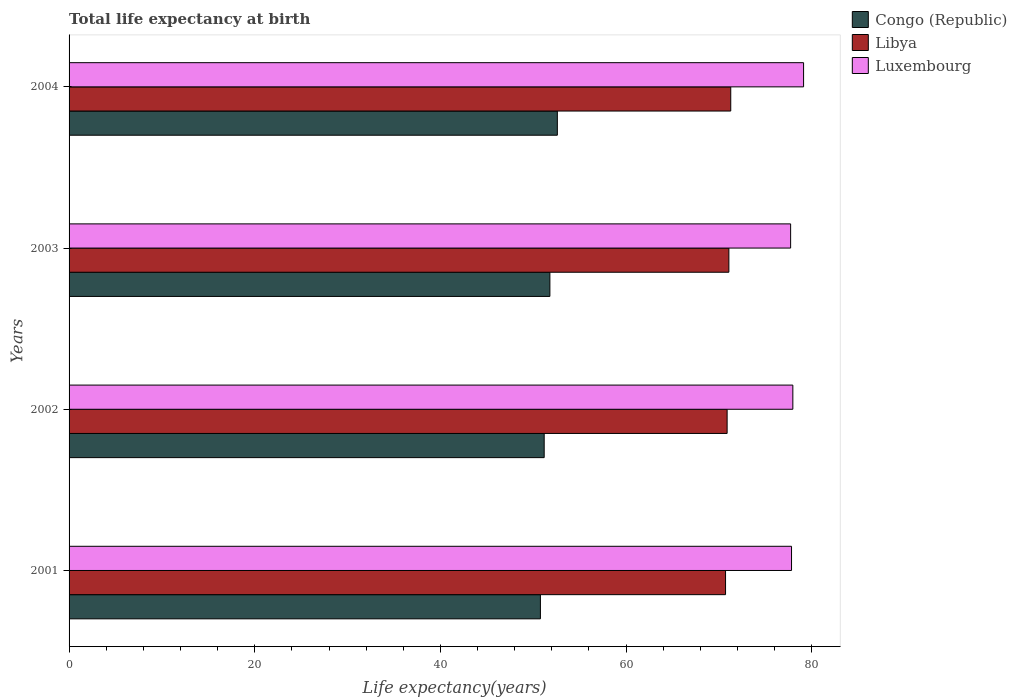How many different coloured bars are there?
Your answer should be very brief. 3. Are the number of bars per tick equal to the number of legend labels?
Your answer should be very brief. Yes. Are the number of bars on each tick of the Y-axis equal?
Provide a short and direct response. Yes. How many bars are there on the 1st tick from the top?
Keep it short and to the point. 3. How many bars are there on the 2nd tick from the bottom?
Your response must be concise. 3. What is the label of the 1st group of bars from the top?
Offer a very short reply. 2004. What is the life expectancy at birth in in Libya in 2002?
Your response must be concise. 70.89. Across all years, what is the maximum life expectancy at birth in in Luxembourg?
Offer a terse response. 79.12. Across all years, what is the minimum life expectancy at birth in in Congo (Republic)?
Ensure brevity in your answer.  50.77. In which year was the life expectancy at birth in in Congo (Republic) maximum?
Make the answer very short. 2004. In which year was the life expectancy at birth in in Luxembourg minimum?
Ensure brevity in your answer.  2003. What is the total life expectancy at birth in in Libya in the graph?
Provide a succinct answer. 283.95. What is the difference between the life expectancy at birth in in Congo (Republic) in 2002 and that in 2004?
Keep it short and to the point. -1.42. What is the difference between the life expectancy at birth in in Congo (Republic) in 2003 and the life expectancy at birth in in Luxembourg in 2002?
Keep it short and to the point. -26.17. What is the average life expectancy at birth in in Congo (Republic) per year?
Provide a short and direct response. 51.59. In the year 2004, what is the difference between the life expectancy at birth in in Libya and life expectancy at birth in in Congo (Republic)?
Offer a very short reply. 18.68. What is the ratio of the life expectancy at birth in in Luxembourg in 2003 to that in 2004?
Ensure brevity in your answer.  0.98. Is the life expectancy at birth in in Libya in 2002 less than that in 2003?
Offer a terse response. Yes. Is the difference between the life expectancy at birth in in Libya in 2001 and 2002 greater than the difference between the life expectancy at birth in in Congo (Republic) in 2001 and 2002?
Your answer should be very brief. Yes. What is the difference between the highest and the second highest life expectancy at birth in in Libya?
Make the answer very short. 0.2. What is the difference between the highest and the lowest life expectancy at birth in in Libya?
Offer a very short reply. 0.56. Is the sum of the life expectancy at birth in in Luxembourg in 2003 and 2004 greater than the maximum life expectancy at birth in in Congo (Republic) across all years?
Ensure brevity in your answer.  Yes. What does the 2nd bar from the top in 2002 represents?
Your answer should be very brief. Libya. What does the 1st bar from the bottom in 2002 represents?
Make the answer very short. Congo (Republic). How many bars are there?
Keep it short and to the point. 12. Are the values on the major ticks of X-axis written in scientific E-notation?
Your response must be concise. No. How many legend labels are there?
Offer a very short reply. 3. What is the title of the graph?
Ensure brevity in your answer.  Total life expectancy at birth. Does "Liberia" appear as one of the legend labels in the graph?
Ensure brevity in your answer.  No. What is the label or title of the X-axis?
Provide a succinct answer. Life expectancy(years). What is the label or title of the Y-axis?
Keep it short and to the point. Years. What is the Life expectancy(years) of Congo (Republic) in 2001?
Offer a terse response. 50.77. What is the Life expectancy(years) in Libya in 2001?
Make the answer very short. 70.72. What is the Life expectancy(years) of Luxembourg in 2001?
Ensure brevity in your answer.  77.82. What is the Life expectancy(years) of Congo (Republic) in 2002?
Your response must be concise. 51.18. What is the Life expectancy(years) of Libya in 2002?
Offer a very short reply. 70.89. What is the Life expectancy(years) of Luxembourg in 2002?
Keep it short and to the point. 77.97. What is the Life expectancy(years) in Congo (Republic) in 2003?
Your response must be concise. 51.79. What is the Life expectancy(years) in Libya in 2003?
Provide a short and direct response. 71.07. What is the Life expectancy(years) in Luxembourg in 2003?
Your response must be concise. 77.73. What is the Life expectancy(years) of Congo (Republic) in 2004?
Your answer should be very brief. 52.6. What is the Life expectancy(years) of Libya in 2004?
Provide a short and direct response. 71.28. What is the Life expectancy(years) of Luxembourg in 2004?
Keep it short and to the point. 79.12. Across all years, what is the maximum Life expectancy(years) in Congo (Republic)?
Give a very brief answer. 52.6. Across all years, what is the maximum Life expectancy(years) of Libya?
Your answer should be very brief. 71.28. Across all years, what is the maximum Life expectancy(years) of Luxembourg?
Make the answer very short. 79.12. Across all years, what is the minimum Life expectancy(years) of Congo (Republic)?
Keep it short and to the point. 50.77. Across all years, what is the minimum Life expectancy(years) in Libya?
Keep it short and to the point. 70.72. Across all years, what is the minimum Life expectancy(years) in Luxembourg?
Your answer should be very brief. 77.73. What is the total Life expectancy(years) in Congo (Republic) in the graph?
Make the answer very short. 206.34. What is the total Life expectancy(years) of Libya in the graph?
Offer a very short reply. 283.95. What is the total Life expectancy(years) in Luxembourg in the graph?
Offer a terse response. 312.64. What is the difference between the Life expectancy(years) of Congo (Republic) in 2001 and that in 2002?
Your response must be concise. -0.41. What is the difference between the Life expectancy(years) of Libya in 2001 and that in 2002?
Offer a terse response. -0.17. What is the difference between the Life expectancy(years) in Luxembourg in 2001 and that in 2002?
Make the answer very short. -0.14. What is the difference between the Life expectancy(years) of Congo (Republic) in 2001 and that in 2003?
Offer a very short reply. -1.02. What is the difference between the Life expectancy(years) of Libya in 2001 and that in 2003?
Your answer should be very brief. -0.36. What is the difference between the Life expectancy(years) in Luxembourg in 2001 and that in 2003?
Make the answer very short. 0.1. What is the difference between the Life expectancy(years) of Congo (Republic) in 2001 and that in 2004?
Ensure brevity in your answer.  -1.82. What is the difference between the Life expectancy(years) of Libya in 2001 and that in 2004?
Keep it short and to the point. -0.56. What is the difference between the Life expectancy(years) of Luxembourg in 2001 and that in 2004?
Make the answer very short. -1.3. What is the difference between the Life expectancy(years) in Congo (Republic) in 2002 and that in 2003?
Provide a short and direct response. -0.61. What is the difference between the Life expectancy(years) in Libya in 2002 and that in 2003?
Offer a terse response. -0.19. What is the difference between the Life expectancy(years) of Luxembourg in 2002 and that in 2003?
Offer a very short reply. 0.24. What is the difference between the Life expectancy(years) of Congo (Republic) in 2002 and that in 2004?
Provide a succinct answer. -1.42. What is the difference between the Life expectancy(years) in Libya in 2002 and that in 2004?
Your answer should be compact. -0.39. What is the difference between the Life expectancy(years) of Luxembourg in 2002 and that in 2004?
Give a very brief answer. -1.16. What is the difference between the Life expectancy(years) in Congo (Republic) in 2003 and that in 2004?
Ensure brevity in your answer.  -0.8. What is the difference between the Life expectancy(years) of Libya in 2003 and that in 2004?
Give a very brief answer. -0.2. What is the difference between the Life expectancy(years) in Luxembourg in 2003 and that in 2004?
Your answer should be very brief. -1.4. What is the difference between the Life expectancy(years) in Congo (Republic) in 2001 and the Life expectancy(years) in Libya in 2002?
Your response must be concise. -20.11. What is the difference between the Life expectancy(years) of Congo (Republic) in 2001 and the Life expectancy(years) of Luxembourg in 2002?
Make the answer very short. -27.19. What is the difference between the Life expectancy(years) in Libya in 2001 and the Life expectancy(years) in Luxembourg in 2002?
Offer a terse response. -7.25. What is the difference between the Life expectancy(years) of Congo (Republic) in 2001 and the Life expectancy(years) of Libya in 2003?
Provide a short and direct response. -20.3. What is the difference between the Life expectancy(years) in Congo (Republic) in 2001 and the Life expectancy(years) in Luxembourg in 2003?
Keep it short and to the point. -26.95. What is the difference between the Life expectancy(years) of Libya in 2001 and the Life expectancy(years) of Luxembourg in 2003?
Provide a succinct answer. -7.01. What is the difference between the Life expectancy(years) in Congo (Republic) in 2001 and the Life expectancy(years) in Libya in 2004?
Provide a succinct answer. -20.5. What is the difference between the Life expectancy(years) of Congo (Republic) in 2001 and the Life expectancy(years) of Luxembourg in 2004?
Your response must be concise. -28.35. What is the difference between the Life expectancy(years) in Libya in 2001 and the Life expectancy(years) in Luxembourg in 2004?
Your answer should be very brief. -8.41. What is the difference between the Life expectancy(years) of Congo (Republic) in 2002 and the Life expectancy(years) of Libya in 2003?
Give a very brief answer. -19.89. What is the difference between the Life expectancy(years) in Congo (Republic) in 2002 and the Life expectancy(years) in Luxembourg in 2003?
Your answer should be compact. -26.55. What is the difference between the Life expectancy(years) of Libya in 2002 and the Life expectancy(years) of Luxembourg in 2003?
Keep it short and to the point. -6.84. What is the difference between the Life expectancy(years) in Congo (Republic) in 2002 and the Life expectancy(years) in Libya in 2004?
Offer a terse response. -20.1. What is the difference between the Life expectancy(years) in Congo (Republic) in 2002 and the Life expectancy(years) in Luxembourg in 2004?
Your response must be concise. -27.94. What is the difference between the Life expectancy(years) of Libya in 2002 and the Life expectancy(years) of Luxembourg in 2004?
Provide a succinct answer. -8.24. What is the difference between the Life expectancy(years) of Congo (Republic) in 2003 and the Life expectancy(years) of Libya in 2004?
Give a very brief answer. -19.48. What is the difference between the Life expectancy(years) in Congo (Republic) in 2003 and the Life expectancy(years) in Luxembourg in 2004?
Your answer should be very brief. -27.33. What is the difference between the Life expectancy(years) of Libya in 2003 and the Life expectancy(years) of Luxembourg in 2004?
Make the answer very short. -8.05. What is the average Life expectancy(years) of Congo (Republic) per year?
Offer a very short reply. 51.59. What is the average Life expectancy(years) in Libya per year?
Your response must be concise. 70.99. What is the average Life expectancy(years) of Luxembourg per year?
Ensure brevity in your answer.  78.16. In the year 2001, what is the difference between the Life expectancy(years) of Congo (Republic) and Life expectancy(years) of Libya?
Keep it short and to the point. -19.94. In the year 2001, what is the difference between the Life expectancy(years) in Congo (Republic) and Life expectancy(years) in Luxembourg?
Your answer should be compact. -27.05. In the year 2001, what is the difference between the Life expectancy(years) in Libya and Life expectancy(years) in Luxembourg?
Your response must be concise. -7.11. In the year 2002, what is the difference between the Life expectancy(years) of Congo (Republic) and Life expectancy(years) of Libya?
Offer a very short reply. -19.71. In the year 2002, what is the difference between the Life expectancy(years) in Congo (Republic) and Life expectancy(years) in Luxembourg?
Your answer should be compact. -26.79. In the year 2002, what is the difference between the Life expectancy(years) in Libya and Life expectancy(years) in Luxembourg?
Your answer should be very brief. -7.08. In the year 2003, what is the difference between the Life expectancy(years) in Congo (Republic) and Life expectancy(years) in Libya?
Your response must be concise. -19.28. In the year 2003, what is the difference between the Life expectancy(years) of Congo (Republic) and Life expectancy(years) of Luxembourg?
Give a very brief answer. -25.93. In the year 2003, what is the difference between the Life expectancy(years) of Libya and Life expectancy(years) of Luxembourg?
Give a very brief answer. -6.65. In the year 2004, what is the difference between the Life expectancy(years) of Congo (Republic) and Life expectancy(years) of Libya?
Provide a short and direct response. -18.68. In the year 2004, what is the difference between the Life expectancy(years) of Congo (Republic) and Life expectancy(years) of Luxembourg?
Provide a succinct answer. -26.52. In the year 2004, what is the difference between the Life expectancy(years) in Libya and Life expectancy(years) in Luxembourg?
Your answer should be very brief. -7.85. What is the ratio of the Life expectancy(years) of Luxembourg in 2001 to that in 2002?
Provide a short and direct response. 1. What is the ratio of the Life expectancy(years) in Congo (Republic) in 2001 to that in 2003?
Ensure brevity in your answer.  0.98. What is the ratio of the Life expectancy(years) of Luxembourg in 2001 to that in 2003?
Keep it short and to the point. 1. What is the ratio of the Life expectancy(years) of Congo (Republic) in 2001 to that in 2004?
Your response must be concise. 0.97. What is the ratio of the Life expectancy(years) in Libya in 2001 to that in 2004?
Provide a succinct answer. 0.99. What is the ratio of the Life expectancy(years) in Luxembourg in 2001 to that in 2004?
Give a very brief answer. 0.98. What is the ratio of the Life expectancy(years) in Libya in 2002 to that in 2003?
Offer a very short reply. 1. What is the ratio of the Life expectancy(years) in Luxembourg in 2002 to that in 2004?
Your response must be concise. 0.99. What is the ratio of the Life expectancy(years) of Congo (Republic) in 2003 to that in 2004?
Offer a very short reply. 0.98. What is the ratio of the Life expectancy(years) in Luxembourg in 2003 to that in 2004?
Make the answer very short. 0.98. What is the difference between the highest and the second highest Life expectancy(years) in Congo (Republic)?
Make the answer very short. 0.8. What is the difference between the highest and the second highest Life expectancy(years) in Libya?
Ensure brevity in your answer.  0.2. What is the difference between the highest and the second highest Life expectancy(years) of Luxembourg?
Make the answer very short. 1.16. What is the difference between the highest and the lowest Life expectancy(years) of Congo (Republic)?
Your answer should be compact. 1.82. What is the difference between the highest and the lowest Life expectancy(years) in Libya?
Make the answer very short. 0.56. What is the difference between the highest and the lowest Life expectancy(years) of Luxembourg?
Provide a short and direct response. 1.4. 